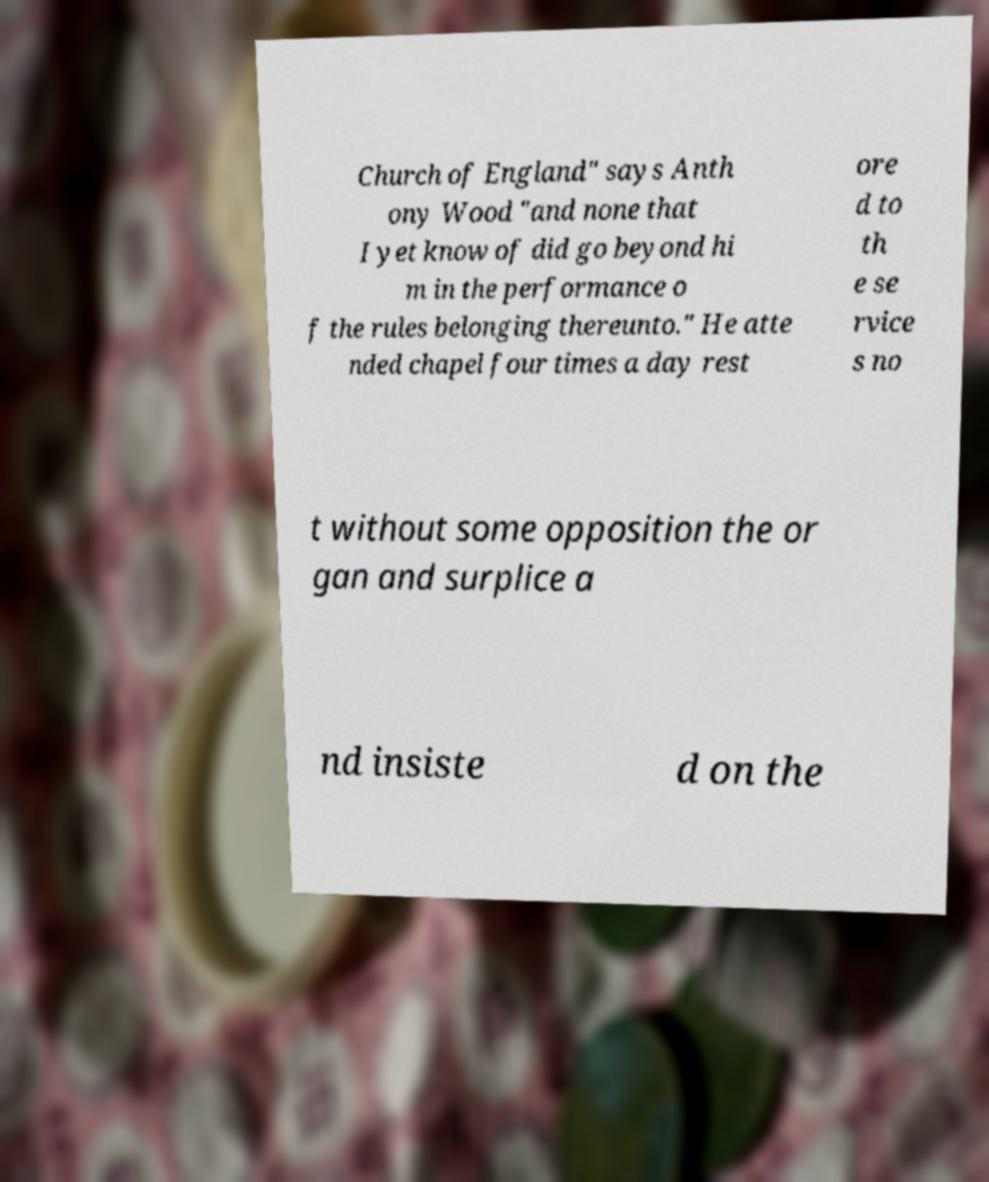For documentation purposes, I need the text within this image transcribed. Could you provide that? Church of England" says Anth ony Wood "and none that I yet know of did go beyond hi m in the performance o f the rules belonging thereunto." He atte nded chapel four times a day rest ore d to th e se rvice s no t without some opposition the or gan and surplice a nd insiste d on the 